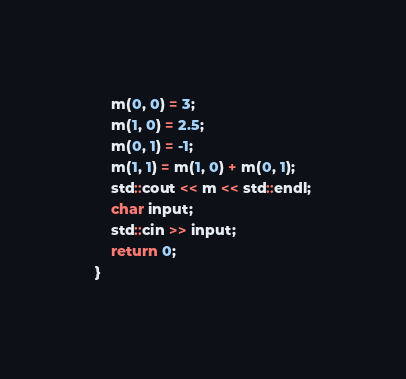Convert code to text. <code><loc_0><loc_0><loc_500><loc_500><_C++_>	m(0, 0) = 3;
	m(1, 0) = 2.5;
	m(0, 1) = -1;
	m(1, 1) = m(1, 0) + m(0, 1);
	std::cout << m << std::endl;
	char input;
	std::cin >> input;
	return 0;
}</code> 